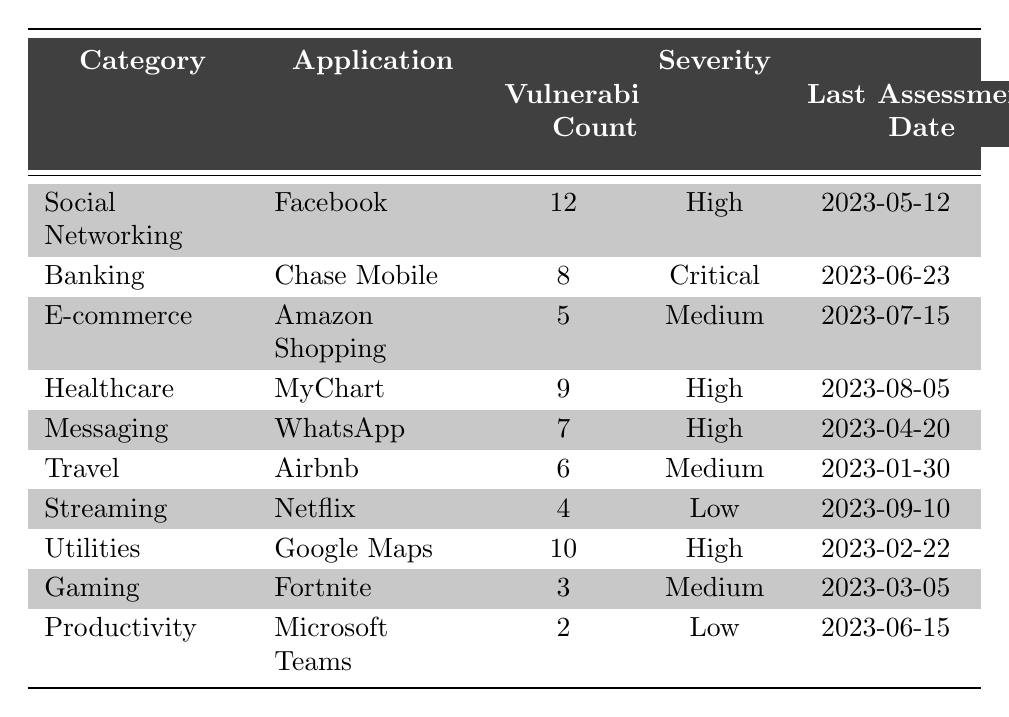What is the application with the highest vulnerability count? From the table, Facebook has the highest vulnerability count of 12.
Answer: Facebook How many applications have a Critical severity level? There is one application, Chase Mobile, that has a Critical severity level according to the table.
Answer: 1 What is the total number of vulnerabilities for applications in the Healthcare category? The only application in the Healthcare category is MyChart, which has 9 vulnerabilities.
Answer: 9 Which application was last assessed on 2023-06-15? According to the table, Microsoft Teams was last assessed on that date.
Answer: Microsoft Teams Are there more applications with High severity or Medium severity? There are four applications with High severity (Facebook, MyChart, WhatsApp, Google Maps) and three applications with Medium severity (Amazon Shopping, Airbnb, Fortnite), so there are more applications with High severity.
Answer: Yes What is the average vulnerability count for applications in the Messaging and E-commerce categories? WhatsApp in the Messaging category has 7 vulnerabilities and Amazon Shopping in the E-commerce category has 5. The average is (7 + 5) / 2 = 6.
Answer: 6 What severity level does the application Netflix have? The table indicates that Netflix has a Low severity level.
Answer: Low Which category has the most vulnerabilities according to the table? The Social Networking category has the highest vulnerability count with Facebook having 12 vulnerabilities.
Answer: Social Networking What is the vulnerability count difference between the application with the highest and the lowest count? The highest is 12 (Facebook) and the lowest is 2 (Microsoft Teams). The difference is 12 - 2 = 10.
Answer: 10 Which applications in the table were last assessed earlier than June 2023? The applications last assessed earlier than June 2023 are Facebook (2023-05-12), WhatsApp (2023-04-20), Google Maps (2023-02-22), Airbnb (2023-01-30), and Fortnite (2023-03-05).
Answer: 5 applications 